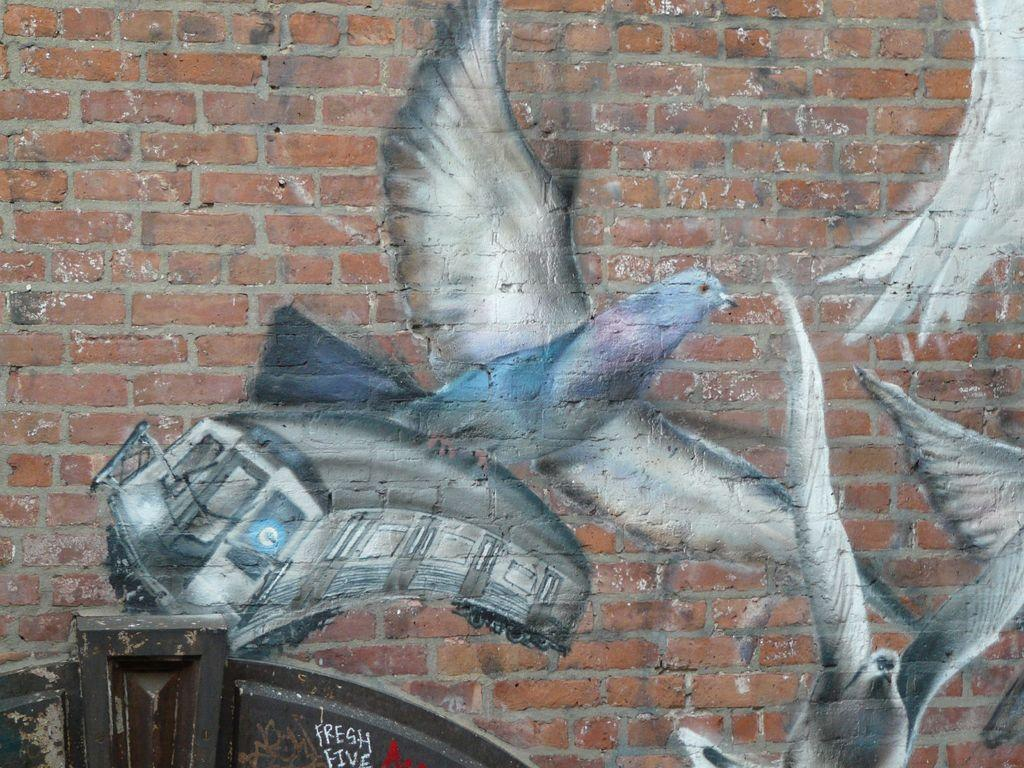What is depicted on the wall in the image? The wall has a painting of birds and a painting of a bus. Can you describe the paintings on the wall? The wall has a painting of birds and a painting of a bus. How many geese are present in the image? There are no geese present in the image; the wall has paintings of birds and a bus. What type of dirt can be seen on the visitor's shoes in the image? There is no visitor or shoes present in the image; it only features a wall with paintings of birds and a bus. 